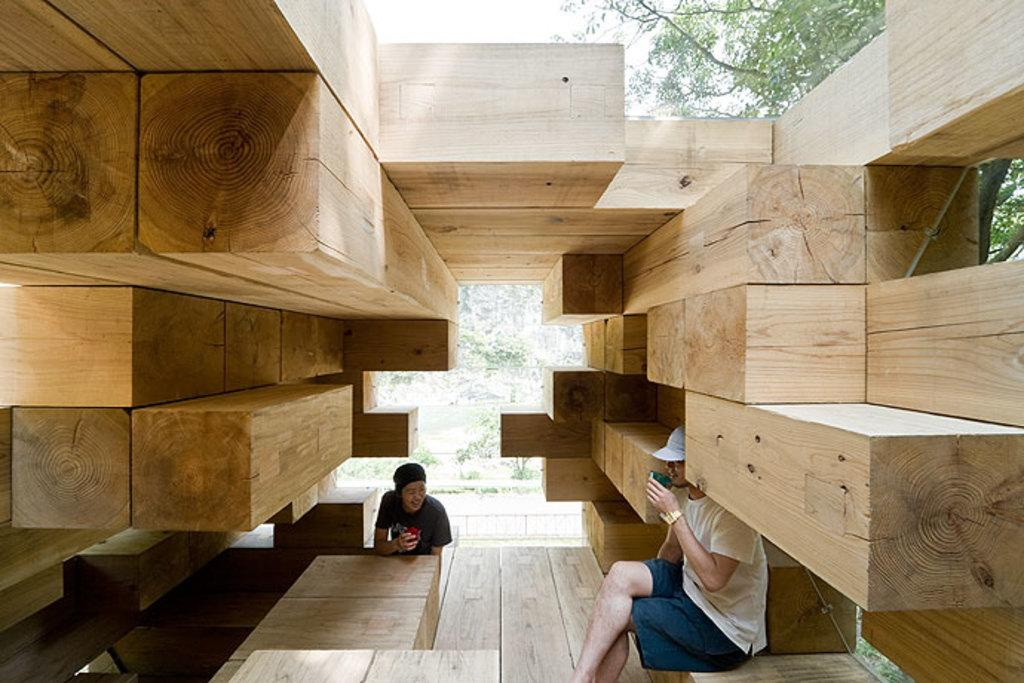How many people are in the image? There are two people in the image. What are the people sitting on? The people are sitting on wooden objects. What can be seen in the background of the image? There are trees visible in the background of the image. What type of whistle can be heard in the image? There is no whistle present in the image, and therefore no sound can be heard. 